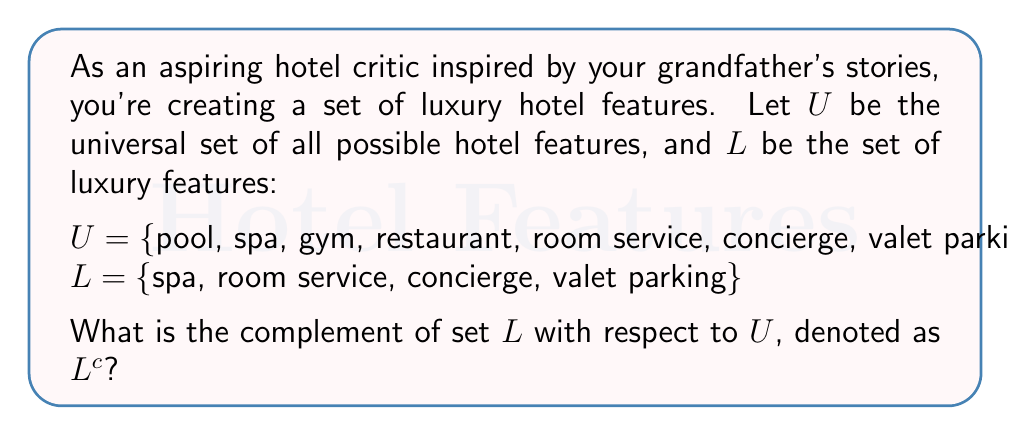What is the answer to this math problem? To find the complement of set $L$ with respect to $U$, we need to identify all elements in $U$ that are not in $L$. Let's follow these steps:

1. Identify elements in $U$:
   $U = \{$pool, spa, gym, restaurant, room service, concierge, valet parking, free Wi-Fi, business center, bar$\}$

2. Identify elements in $L$:
   $L = \{$spa, room service, concierge, valet parking$\}$

3. Find elements in $U$ that are not in $L$:
   - pool
   - gym
   - restaurant
   - free Wi-Fi
   - business center
   - bar

4. The complement of $L$, denoted as $L^c$, is the set of these elements:
   $L^c = \{$pool, gym, restaurant, free Wi-Fi, business center, bar$\}$

This set represents all the hotel features in the universal set that are not considered luxury features in set $L$.
Answer: $L^c = \{$pool, gym, restaurant, free Wi-Fi, business center, bar$\}$ 